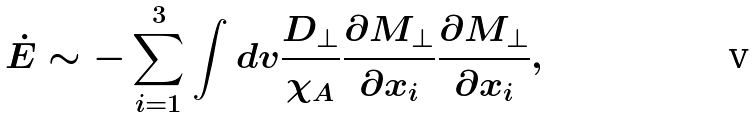<formula> <loc_0><loc_0><loc_500><loc_500>\dot { E } \sim - \sum _ { i = 1 } ^ { 3 } \int d v \frac { D _ { \perp } } { \chi _ { A } } \frac { \partial M _ { \perp } } { \partial x _ { i } } \frac { \partial M _ { \perp } } { \partial x _ { i } } ,</formula> 